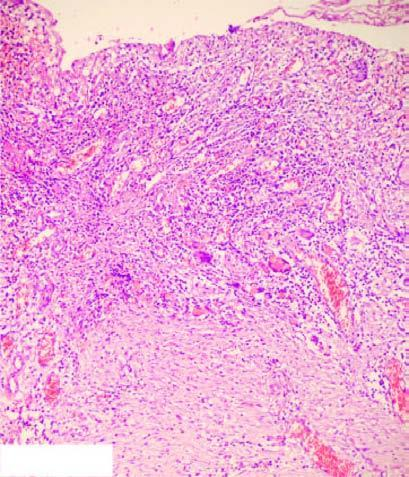what shows necrotic debris, ulceration and inflammation on the mucosal surface?
Answer the question using a single word or phrase. Photomicrograph on right 